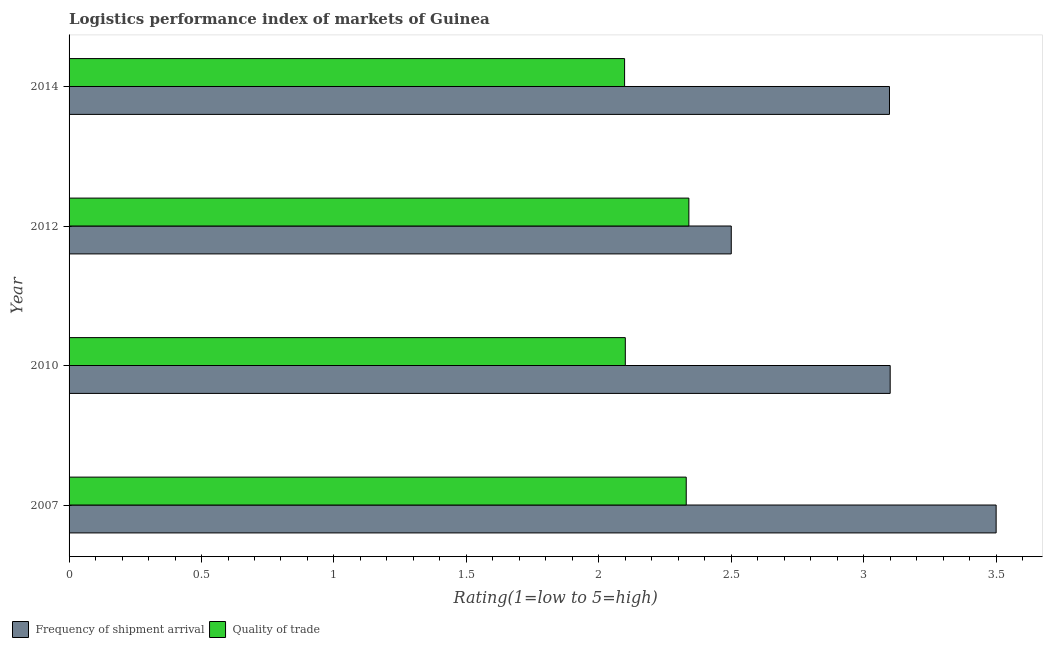How many different coloured bars are there?
Give a very brief answer. 2. How many groups of bars are there?
Offer a terse response. 4. What is the label of the 3rd group of bars from the top?
Provide a succinct answer. 2010. Across all years, what is the maximum lpi of frequency of shipment arrival?
Offer a very short reply. 3.5. Across all years, what is the minimum lpi quality of trade?
Offer a very short reply. 2.1. In which year was the lpi quality of trade maximum?
Provide a short and direct response. 2012. What is the total lpi quality of trade in the graph?
Give a very brief answer. 8.87. What is the difference between the lpi of frequency of shipment arrival in 2007 and that in 2014?
Your answer should be compact. 0.4. What is the difference between the lpi of frequency of shipment arrival in 2010 and the lpi quality of trade in 2014?
Keep it short and to the point. 1. What is the average lpi quality of trade per year?
Make the answer very short. 2.22. In how many years, is the lpi of frequency of shipment arrival greater than 0.9 ?
Make the answer very short. 4. What is the ratio of the lpi of frequency of shipment arrival in 2007 to that in 2010?
Provide a succinct answer. 1.13. Is the lpi quality of trade in 2010 less than that in 2014?
Give a very brief answer. No. What is the difference between the highest and the second highest lpi of frequency of shipment arrival?
Ensure brevity in your answer.  0.4. What is the difference between the highest and the lowest lpi of frequency of shipment arrival?
Provide a succinct answer. 1. Is the sum of the lpi quality of trade in 2007 and 2010 greater than the maximum lpi of frequency of shipment arrival across all years?
Provide a short and direct response. Yes. What does the 2nd bar from the top in 2010 represents?
Keep it short and to the point. Frequency of shipment arrival. What does the 1st bar from the bottom in 2014 represents?
Ensure brevity in your answer.  Frequency of shipment arrival. How many years are there in the graph?
Provide a succinct answer. 4. What is the difference between two consecutive major ticks on the X-axis?
Offer a terse response. 0.5. Are the values on the major ticks of X-axis written in scientific E-notation?
Provide a short and direct response. No. Does the graph contain any zero values?
Your answer should be compact. No. Where does the legend appear in the graph?
Provide a short and direct response. Bottom left. How are the legend labels stacked?
Provide a short and direct response. Horizontal. What is the title of the graph?
Provide a short and direct response. Logistics performance index of markets of Guinea. What is the label or title of the X-axis?
Offer a terse response. Rating(1=low to 5=high). What is the Rating(1=low to 5=high) in Frequency of shipment arrival in 2007?
Keep it short and to the point. 3.5. What is the Rating(1=low to 5=high) in Quality of trade in 2007?
Offer a very short reply. 2.33. What is the Rating(1=low to 5=high) in Frequency of shipment arrival in 2010?
Ensure brevity in your answer.  3.1. What is the Rating(1=low to 5=high) in Quality of trade in 2012?
Offer a very short reply. 2.34. What is the Rating(1=low to 5=high) in Frequency of shipment arrival in 2014?
Your response must be concise. 3.1. What is the Rating(1=low to 5=high) of Quality of trade in 2014?
Provide a succinct answer. 2.1. Across all years, what is the maximum Rating(1=low to 5=high) in Quality of trade?
Make the answer very short. 2.34. Across all years, what is the minimum Rating(1=low to 5=high) of Quality of trade?
Ensure brevity in your answer.  2.1. What is the total Rating(1=low to 5=high) of Frequency of shipment arrival in the graph?
Provide a succinct answer. 12.2. What is the total Rating(1=low to 5=high) of Quality of trade in the graph?
Your answer should be very brief. 8.87. What is the difference between the Rating(1=low to 5=high) of Frequency of shipment arrival in 2007 and that in 2010?
Offer a very short reply. 0.4. What is the difference between the Rating(1=low to 5=high) of Quality of trade in 2007 and that in 2010?
Your response must be concise. 0.23. What is the difference between the Rating(1=low to 5=high) in Frequency of shipment arrival in 2007 and that in 2012?
Provide a short and direct response. 1. What is the difference between the Rating(1=low to 5=high) of Quality of trade in 2007 and that in 2012?
Provide a short and direct response. -0.01. What is the difference between the Rating(1=low to 5=high) in Frequency of shipment arrival in 2007 and that in 2014?
Make the answer very short. 0.4. What is the difference between the Rating(1=low to 5=high) in Quality of trade in 2007 and that in 2014?
Your answer should be compact. 0.23. What is the difference between the Rating(1=low to 5=high) of Quality of trade in 2010 and that in 2012?
Your answer should be very brief. -0.24. What is the difference between the Rating(1=low to 5=high) in Frequency of shipment arrival in 2010 and that in 2014?
Keep it short and to the point. 0. What is the difference between the Rating(1=low to 5=high) in Quality of trade in 2010 and that in 2014?
Keep it short and to the point. 0. What is the difference between the Rating(1=low to 5=high) in Frequency of shipment arrival in 2012 and that in 2014?
Your answer should be very brief. -0.6. What is the difference between the Rating(1=low to 5=high) in Quality of trade in 2012 and that in 2014?
Give a very brief answer. 0.24. What is the difference between the Rating(1=low to 5=high) in Frequency of shipment arrival in 2007 and the Rating(1=low to 5=high) in Quality of trade in 2010?
Your answer should be very brief. 1.4. What is the difference between the Rating(1=low to 5=high) of Frequency of shipment arrival in 2007 and the Rating(1=low to 5=high) of Quality of trade in 2012?
Make the answer very short. 1.16. What is the difference between the Rating(1=low to 5=high) in Frequency of shipment arrival in 2007 and the Rating(1=low to 5=high) in Quality of trade in 2014?
Your answer should be compact. 1.4. What is the difference between the Rating(1=low to 5=high) in Frequency of shipment arrival in 2010 and the Rating(1=low to 5=high) in Quality of trade in 2012?
Your answer should be very brief. 0.76. What is the difference between the Rating(1=low to 5=high) of Frequency of shipment arrival in 2012 and the Rating(1=low to 5=high) of Quality of trade in 2014?
Provide a succinct answer. 0.4. What is the average Rating(1=low to 5=high) of Frequency of shipment arrival per year?
Provide a succinct answer. 3.05. What is the average Rating(1=low to 5=high) of Quality of trade per year?
Offer a very short reply. 2.22. In the year 2007, what is the difference between the Rating(1=low to 5=high) in Frequency of shipment arrival and Rating(1=low to 5=high) in Quality of trade?
Give a very brief answer. 1.17. In the year 2010, what is the difference between the Rating(1=low to 5=high) of Frequency of shipment arrival and Rating(1=low to 5=high) of Quality of trade?
Keep it short and to the point. 1. In the year 2012, what is the difference between the Rating(1=low to 5=high) in Frequency of shipment arrival and Rating(1=low to 5=high) in Quality of trade?
Offer a terse response. 0.16. In the year 2014, what is the difference between the Rating(1=low to 5=high) of Frequency of shipment arrival and Rating(1=low to 5=high) of Quality of trade?
Offer a very short reply. 1. What is the ratio of the Rating(1=low to 5=high) of Frequency of shipment arrival in 2007 to that in 2010?
Provide a succinct answer. 1.13. What is the ratio of the Rating(1=low to 5=high) of Quality of trade in 2007 to that in 2010?
Offer a very short reply. 1.11. What is the ratio of the Rating(1=low to 5=high) in Frequency of shipment arrival in 2007 to that in 2014?
Offer a very short reply. 1.13. What is the ratio of the Rating(1=low to 5=high) in Quality of trade in 2007 to that in 2014?
Your response must be concise. 1.11. What is the ratio of the Rating(1=low to 5=high) of Frequency of shipment arrival in 2010 to that in 2012?
Ensure brevity in your answer.  1.24. What is the ratio of the Rating(1=low to 5=high) of Quality of trade in 2010 to that in 2012?
Keep it short and to the point. 0.9. What is the ratio of the Rating(1=low to 5=high) in Frequency of shipment arrival in 2012 to that in 2014?
Make the answer very short. 0.81. What is the ratio of the Rating(1=low to 5=high) in Quality of trade in 2012 to that in 2014?
Provide a short and direct response. 1.12. What is the difference between the highest and the second highest Rating(1=low to 5=high) of Quality of trade?
Keep it short and to the point. 0.01. What is the difference between the highest and the lowest Rating(1=low to 5=high) in Frequency of shipment arrival?
Offer a very short reply. 1. What is the difference between the highest and the lowest Rating(1=low to 5=high) of Quality of trade?
Ensure brevity in your answer.  0.24. 